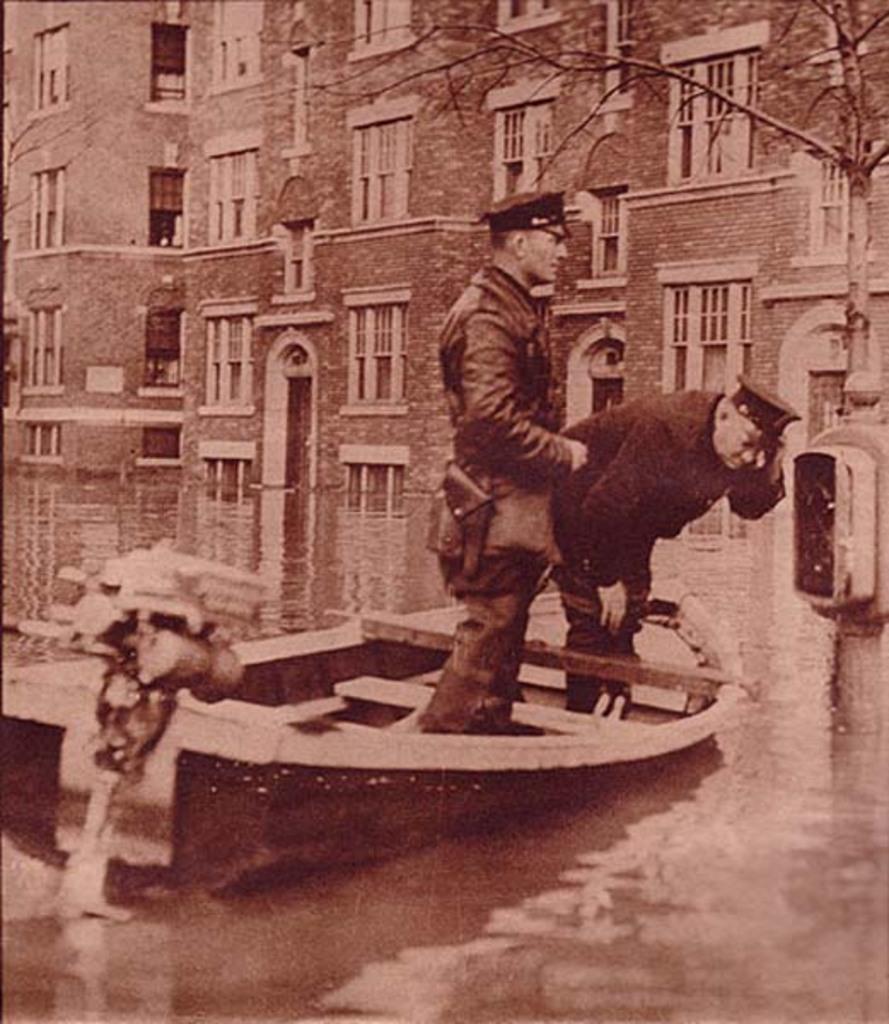Please provide a concise description of this image. In the foreground of the picture there is a water body, in the water there is a boat, in the boat we can see two persons. In the background there are buildings and a tree. 